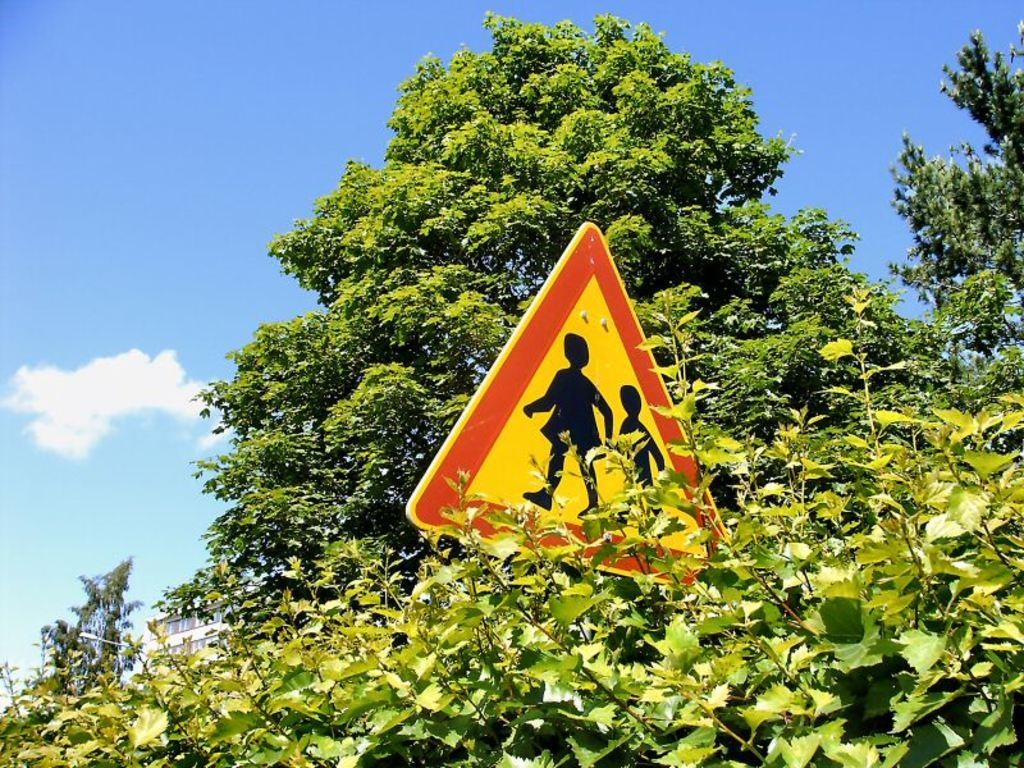What type of vegetation can be seen in the image? There are trees in the image. What is located in the center of the image? There is a sign board in the center of the image. What can be seen in the background of the image? There is sky visible in the background of the image. Can you see a bird using a hose in the image? There is no bird or hose present in the image. What type of train is visible in the image? There is no train present in the image. 